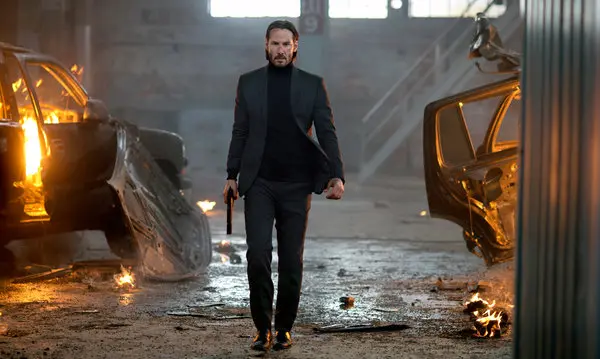What is happening in this image? In the image, a man is moving through a dimly lit, chaotic scene, possibly a warehouse. The setting is filled with burning cars and scattered debris, indicating a recent battle or explosion. The man, dressed in a black suit and turtleneck, holds a gun in his right hand and seems to be in pursuit of something or someone. What can you say about the man's expression and overall demeanor? The man's expression is one of intense focus and determination. His overall demeanor exudes confidence and readiness, suggesting that he is prepared for the danger that surrounds him. The way he strides forward, seemingly unphased by the destruction around him, implies that he is a formidable and experienced individual, likely used to dealing with high-stakes situations. Could you describe a possible backstory for this character? This character could be a seasoned undercover agent or a highly skilled assassin. His attire, a black suit and turtleneck, hints at his professional approach and possibly his affiliation with a covert organization. The chaotic environment and his calm yet alert demeanor suggest he is on a mission, perhaps seeking vengeance or trying to thwart a critical threat. The destruction around him indicates he has been in the midst of a fierce confrontation, and his unwavering stride suggests he is steadfastly moving towards his objective, undeterred by the obstacles in his path. 